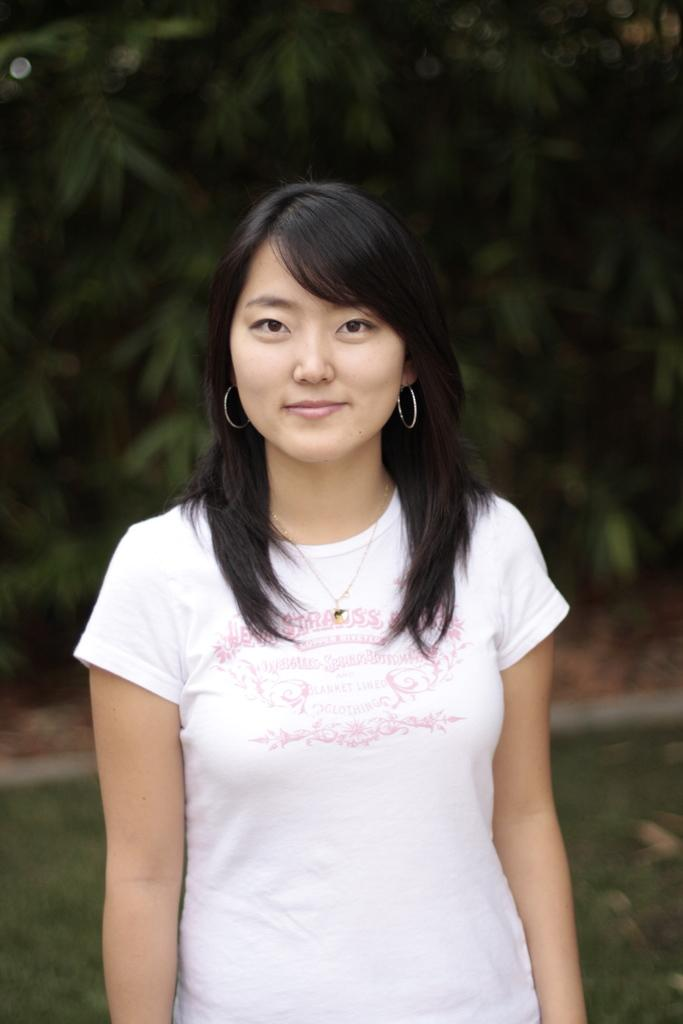Who is the main subject in the image? There is a woman in the image. What is the woman doing in the image? The woman is standing and smiling. What is the woman wearing in the image? The woman is wearing a white color T-shirt. Can you describe the background of the image? The background of the image is blurred. What type of class is being taught in the image? There is no class or teaching activity present in the image; it features a woman standing and smiling. How many rays of sunlight can be seen in the image? There are no rays of sunlight visible in the image, as the background is blurred and does not show any specific lighting conditions. 